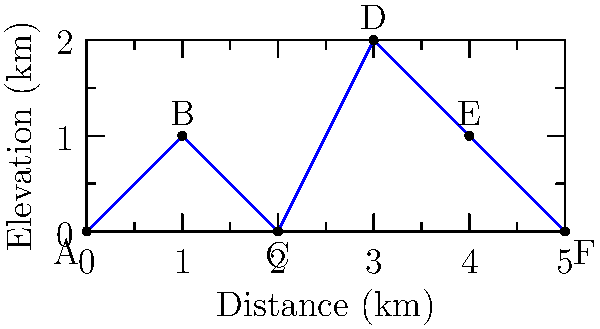Given the terrain profile of a rural area, where points A to F represent potential writing spots, determine the most secluded location for crafting your next romantic novel. Consider that seclusion is defined by the highest elevation and furthest distance from both endpoints (A and F). To find the most secluded writing spot, we need to consider both elevation and distance from the endpoints. Let's analyze each point:

1. Point A: Elevation 0 km, distance 0 km from endpoint A
2. Point B: Elevation 1 km, distance 1 km from endpoint A
3. Point C: Elevation 0 km, distance 2 km from endpoint A
4. Point D: Elevation 2 km, distance 3 km from endpoint A
5. Point E: Elevation 1 km, distance 4 km from endpoint A
6. Point F: Elevation 0 km, distance 5 km from endpoint A (0 km from endpoint F)

Point D has the highest elevation at 2 km. It's also located at the midpoint of the terrain profile, 3 km from both endpoints A and F. This makes it the most secluded spot, offering both height advantage and equal distance from both ends of the mapped area.

Point E, while further from endpoint A, is closer to endpoint F and has a lower elevation than D.

Point B, despite having some elevation, is too close to endpoint A to be considered secluded.

Therefore, Point D offers the best combination of elevation and distance from both endpoints, making it the most secluded writing spot for our privacy-valuing romance novelist.
Answer: Point D 